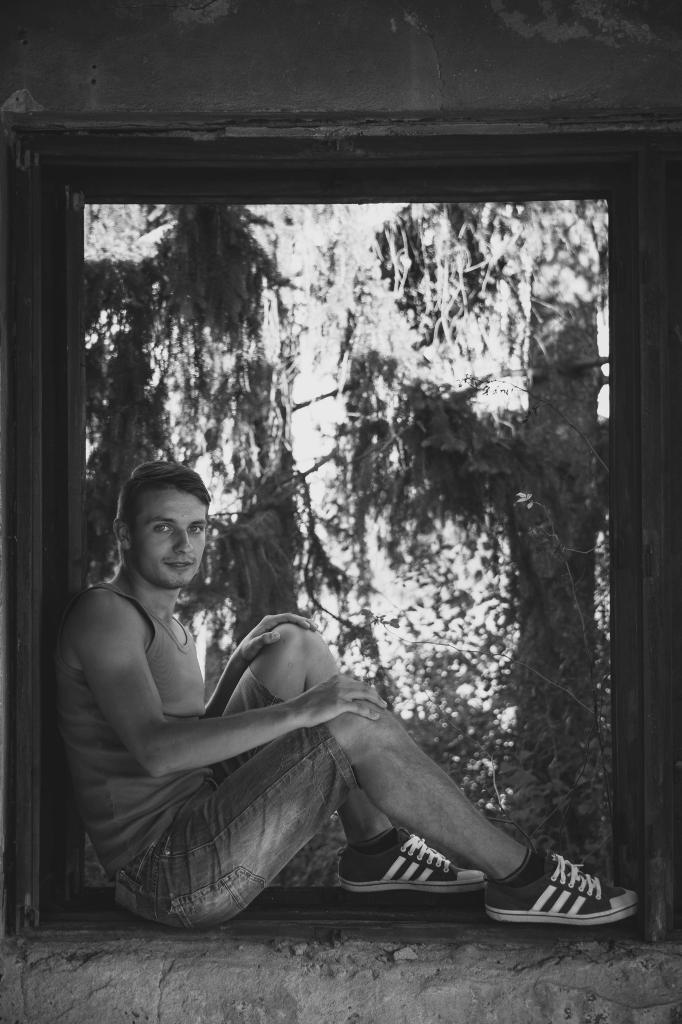What is the color scheme of the image? The image is black and white. Who is present in the image? There is a man in the image. What is the man doing in the image? The man is sitting on a wall in the image. Where is the man sitting in the image? The man is sitting on a wall in the image. What is the man wearing on his feet? The man is wearing shoes in the image. What can be seen in the background of the image? There is a tree trunk visible in the background of the image. How is the tree trunk depicted in the image? The tree trunk appears blurry in the background. What type of marble is the man holding in the image? There is no marble present in the image. 